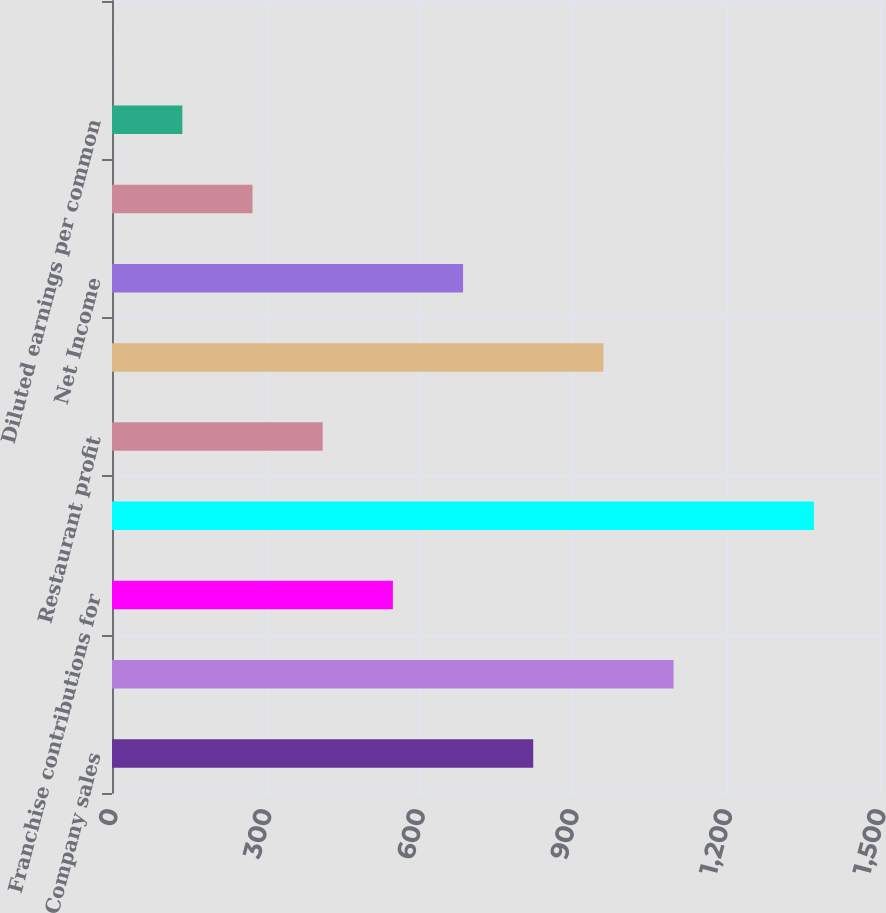<chart> <loc_0><loc_0><loc_500><loc_500><bar_chart><fcel>Company sales<fcel>Franchise and property<fcel>Franchise contributions for<fcel>Total revenues<fcel>Restaurant profit<fcel>Operating Profit (a)<fcel>Net Income<fcel>Basic earnings per common<fcel>Diluted earnings per common<fcel>Dividends declared per common<nl><fcel>822.72<fcel>1096.84<fcel>548.6<fcel>1371<fcel>411.54<fcel>959.78<fcel>685.66<fcel>274.48<fcel>137.42<fcel>0.36<nl></chart> 